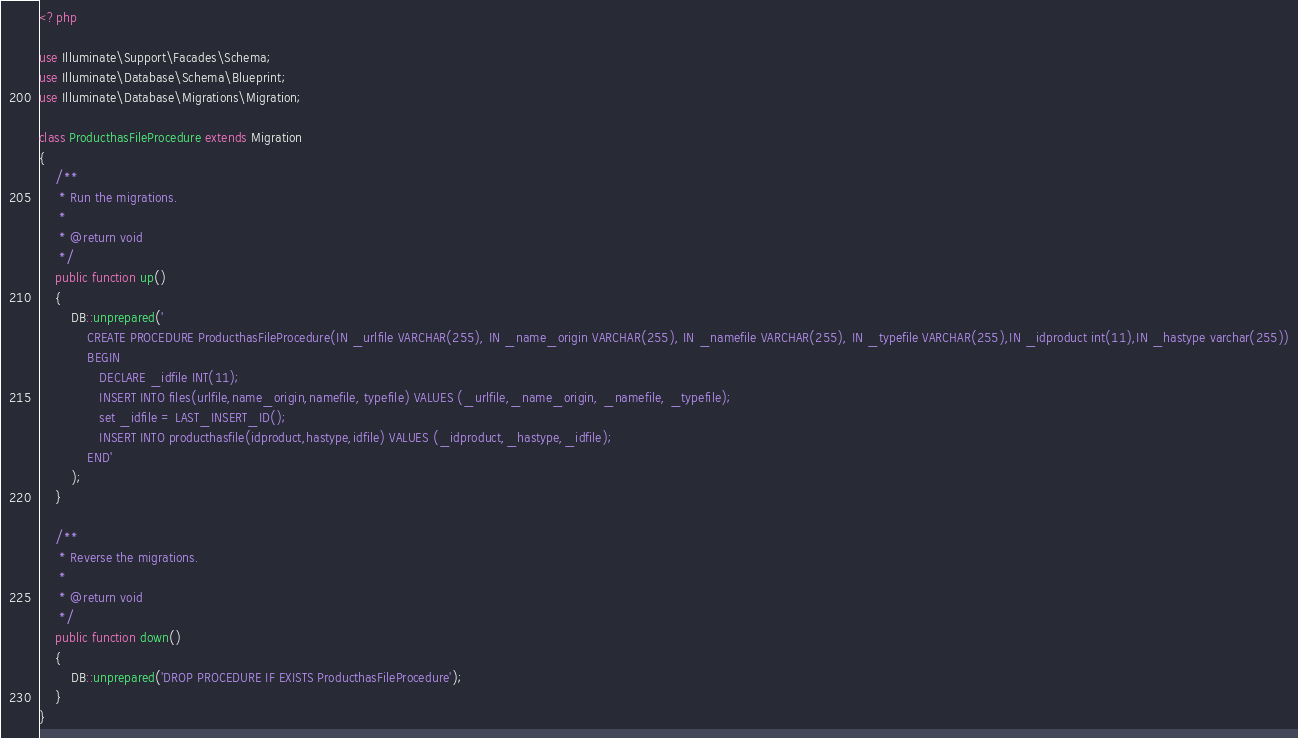<code> <loc_0><loc_0><loc_500><loc_500><_PHP_><?php

use Illuminate\Support\Facades\Schema;
use Illuminate\Database\Schema\Blueprint;
use Illuminate\Database\Migrations\Migration;

class ProducthasFileProcedure extends Migration
{
    /**
     * Run the migrations.
     *
     * @return void
     */
    public function up()
    {
        DB::unprepared('
            CREATE PROCEDURE ProducthasFileProcedure(IN _urlfile VARCHAR(255), IN _name_origin VARCHAR(255), IN _namefile VARCHAR(255), IN _typefile VARCHAR(255),IN _idproduct int(11),IN _hastype varchar(255))
            BEGIN
               DECLARE _idfile INT(11);
               INSERT INTO files(urlfile,name_origin,namefile, typefile) VALUES (_urlfile,_name_origin, _namefile, _typefile);
               set _idfile = LAST_INSERT_ID();
               INSERT INTO producthasfile(idproduct,hastype,idfile) VALUES (_idproduct,_hastype,_idfile);
            END'
        );
    }

    /**
     * Reverse the migrations.
     *
     * @return void
     */
    public function down()
    {
        DB::unprepared('DROP PROCEDURE IF EXISTS ProducthasFileProcedure');
    }
}
</code> 